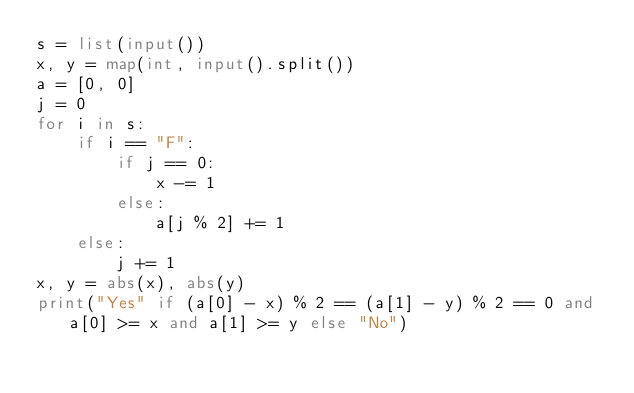Convert code to text. <code><loc_0><loc_0><loc_500><loc_500><_Python_>s = list(input())
x, y = map(int, input().split())
a = [0, 0]
j = 0
for i in s:
    if i == "F":
        if j == 0:
            x -= 1
        else:
            a[j % 2] += 1
    else:
        j += 1
x, y = abs(x), abs(y)
print("Yes" if (a[0] - x) % 2 == (a[1] - y) % 2 == 0 and a[0] >= x and a[1] >= y else "No")</code> 